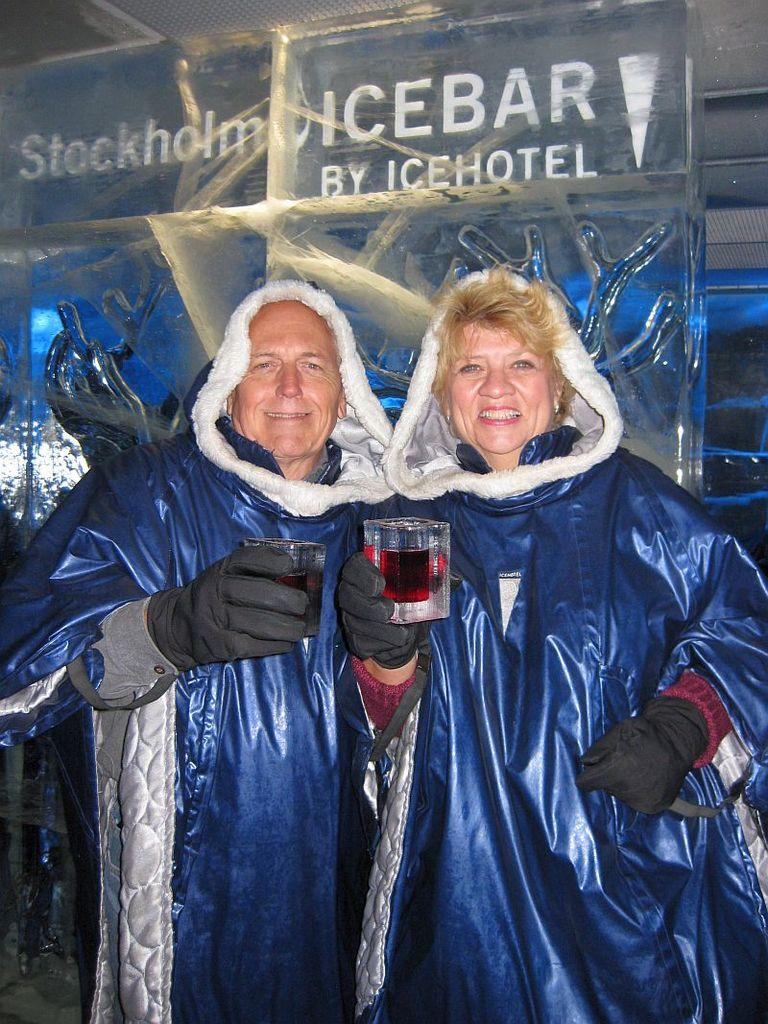<image>
Relay a brief, clear account of the picture shown. A man and a woman at an icebar hotel wearing heavy clothing while holding up glasses. 